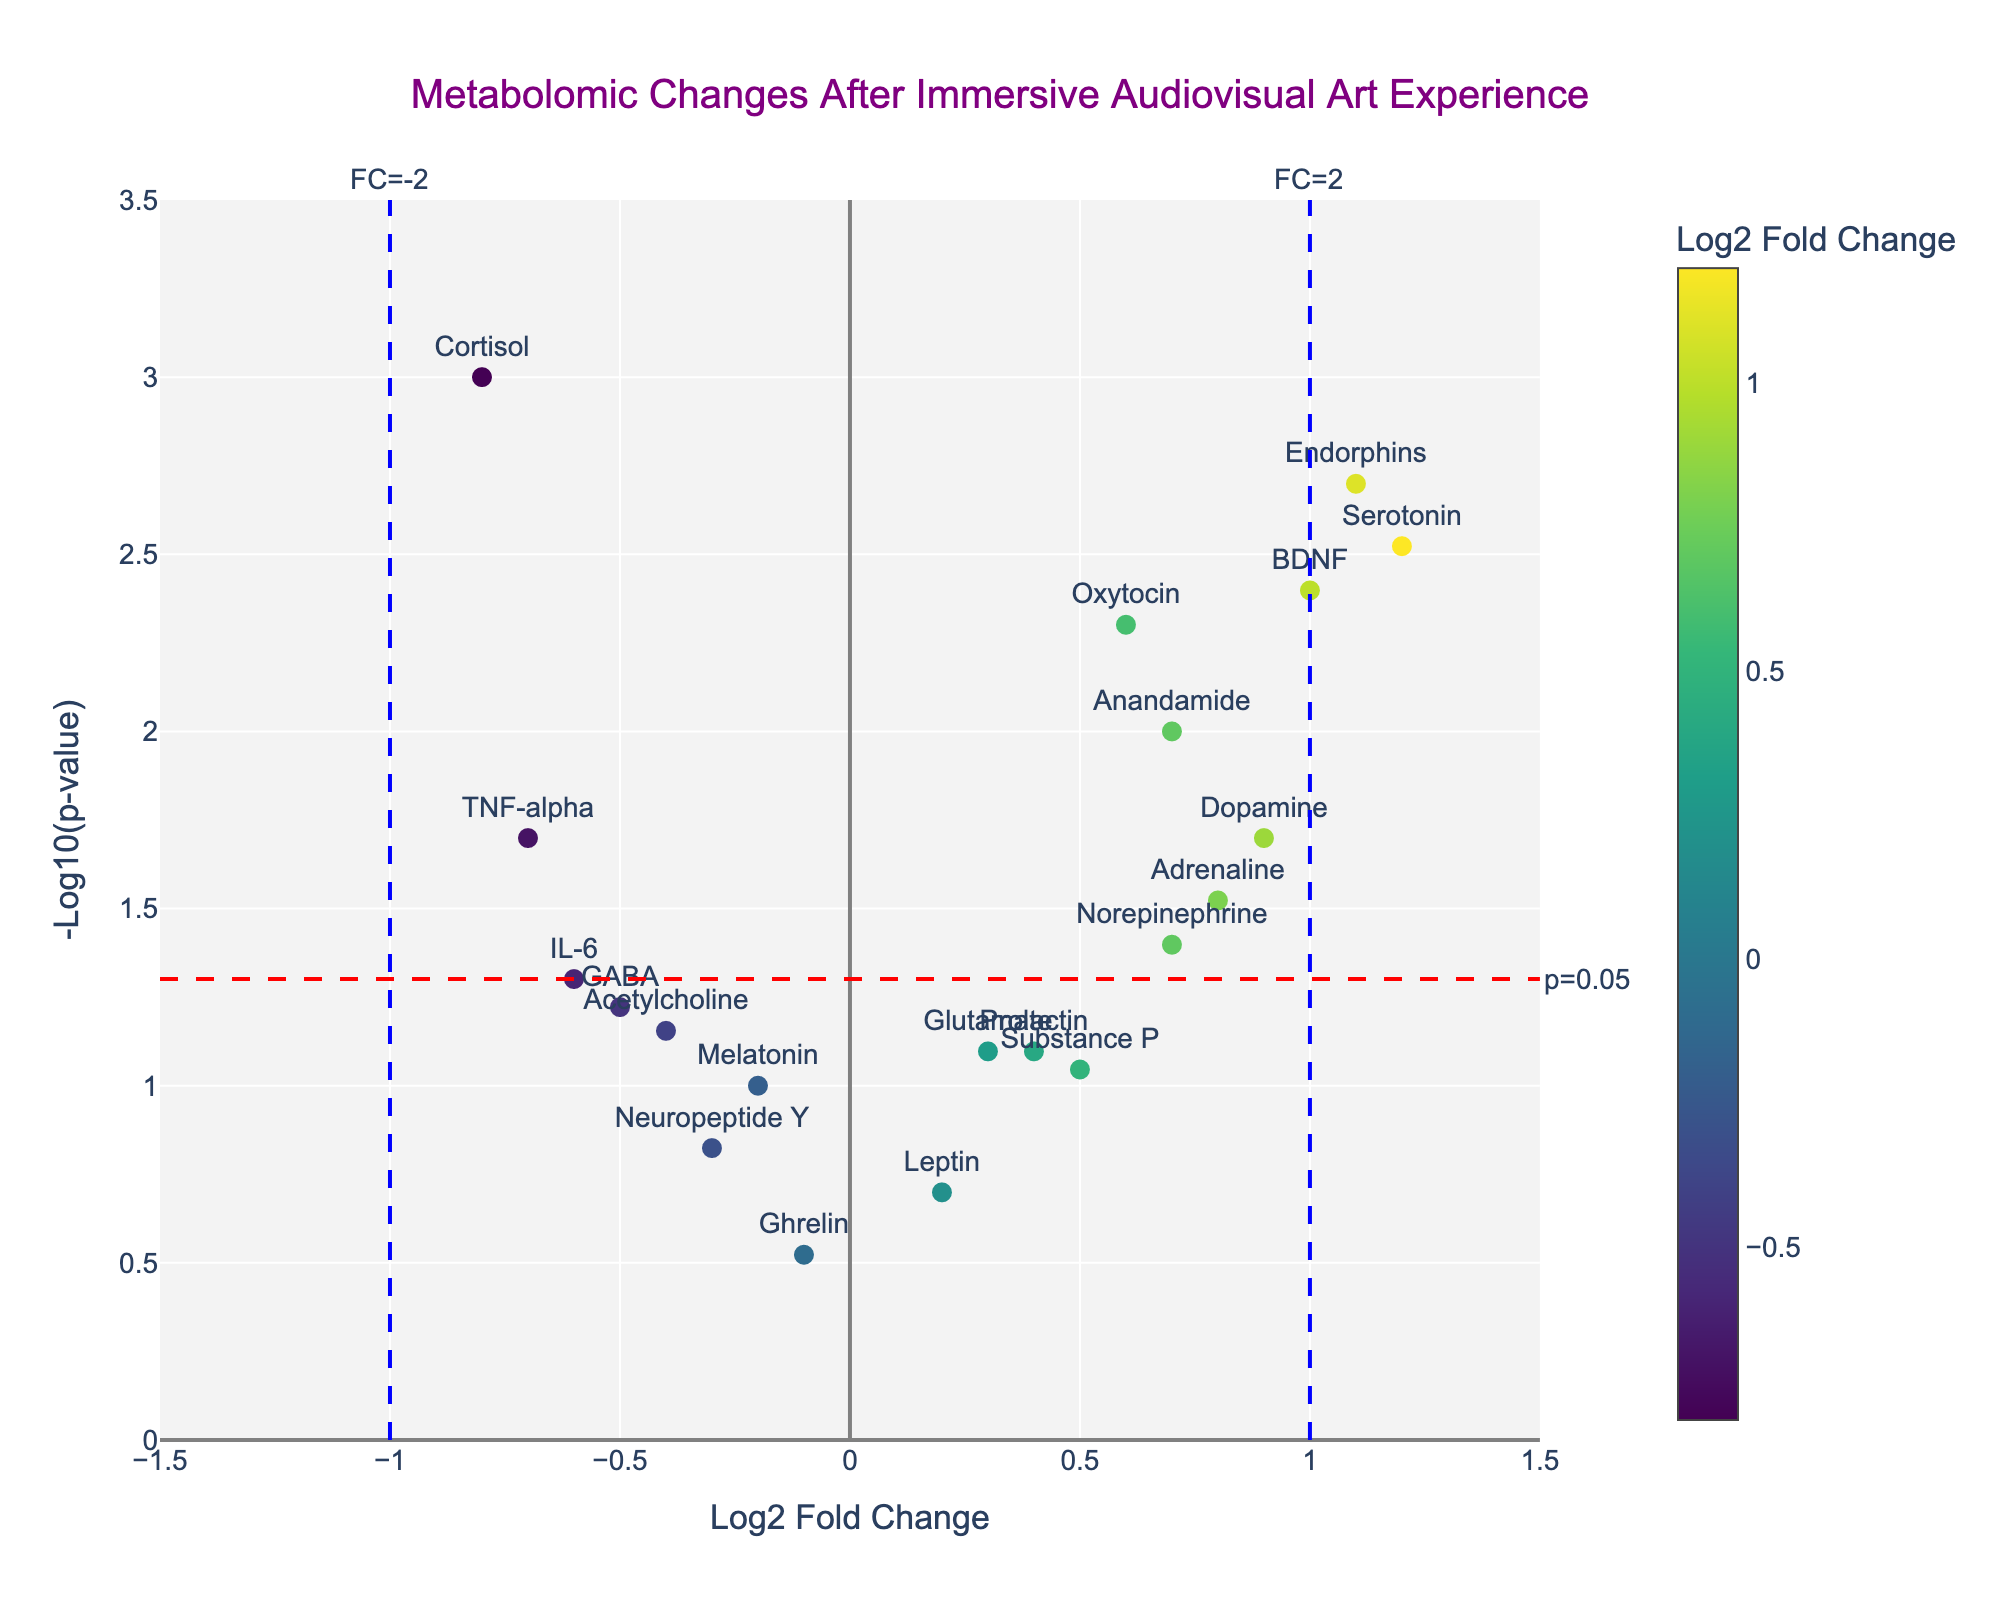What's the title of the figure? The title is displayed at the top of the figure, generally in a larger font size and often in bold. In this specific plot, the title text is "Metabolomic Changes After Immersive Audiovisual Art Experience."
Answer: Metabolomic Changes After Immersive Audiovisual Art Experience Which gene has the highest log2 fold change? To find the gene with the highest log2 fold change, look for the data point farthest to the right on the x-axis. Based on the provided data, the gene with the highest log2 fold change is "Serotonin" with a value of 1.2.
Answer: Serotonin Which gene is associated with the lowest p-value? To determine the gene with the lowest p-value, identify the data point that is positioned highest on the y-axis since p-values are transformed using -log10. "Cortisol" has the smallest p-value and thus the highest -log10(p-value) value.
Answer: Cortisol How many genes have a significant p-value (p<0.05)? Significant p-values (p<0.05) correspond to points above the horizontal red line. By checking the data, "Cortisol," "Serotonin," "Dopamine," "Oxytocin," "Endorphins," "Anandamide," "BDNF," and "TNF-alpha" meet this criterion. In total, there are 8 genes.
Answer: 8 Which gene has the largest negative log2 fold change? Look for the data points farthest to the left on the x-axis, which corresponds to negative log2 fold changes. The gene "Cortisol" has the largest negative log2 fold change at -0.8.
Answer: Cortisol Are there any genes with a log2 fold change between -0.2 and 0.2? Refer to the data points that lie within the range of -0.2 to 0.2 on the x-axis. Based on the provided data, "Glutamate," "Melatonin," "Leptin," and "Ghrelin" fall within this range.
Answer: Yes How many genes have a log2 fold change greater than 1? Data points to the right of the vertical blue line at 1 on the x-axis represent genes with log2 fold changes greater than 1. Consult the dataset to identify these genes as "Serotonin" and "Endorphins."
Answer: 2 Which gene has the highest -log10(p-value) but a log2 fold change less than 0? From the dataset, identify points that lie above the horizontal red line for significance and left of x=0 for negative fold change. "Cortisol," with a -log10(p-value) corresponding to p=0.001 and log2 fold change of -0.8, fits this description.
Answer: Cortisol Is there any gene that has a log2 fold change greater than 0.5 but is not statistically significant (p ≥ 0.05)? Investigate points to the right of x=0.5 and below the horizontal red line indicating non-significance. According to the data, "Substance P" fits this criterion.
Answer: Substance P Which gene has the smallest -log10(p-value) while maintaining a log2 fold change greater than or equal to 0.5? From the data, look for points with larger x-values but lower y-values. "Adrenaline," with a log2 fold change of 0.8 and p=0.03, meets these conditions.
Answer: Adrenaline 